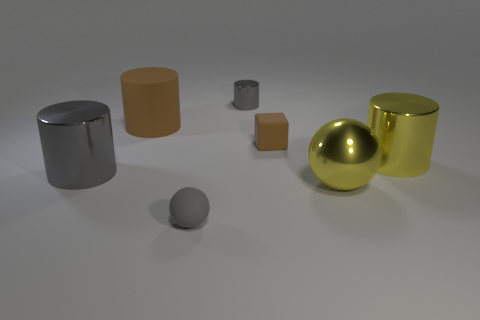There is a brown block that is the same size as the gray rubber ball; what material is it?
Keep it short and to the point. Rubber. Does the shiny thing that is left of the small gray sphere have the same color as the sphere that is in front of the metal ball?
Offer a terse response. Yes. What shape is the large yellow shiny object that is in front of the metallic thing that is on the left side of the large brown rubber cylinder?
Make the answer very short. Sphere. How many other things are the same color as the tiny metal cylinder?
Provide a short and direct response. 2. Do the gray ball and the big gray cylinder have the same material?
Ensure brevity in your answer.  No. Is there a large cylinder of the same color as the rubber sphere?
Give a very brief answer. Yes. The brown cylinder has what size?
Your answer should be compact. Large. Does the small rubber ball have the same color as the tiny metal thing?
Ensure brevity in your answer.  Yes. How many objects are small brown cubes or matte objects on the left side of the tiny gray matte ball?
Your answer should be compact. 2. How many big metal things are in front of the gray shiny cylinder that is in front of the tiny gray metallic object behind the small brown matte cube?
Offer a very short reply. 1. 